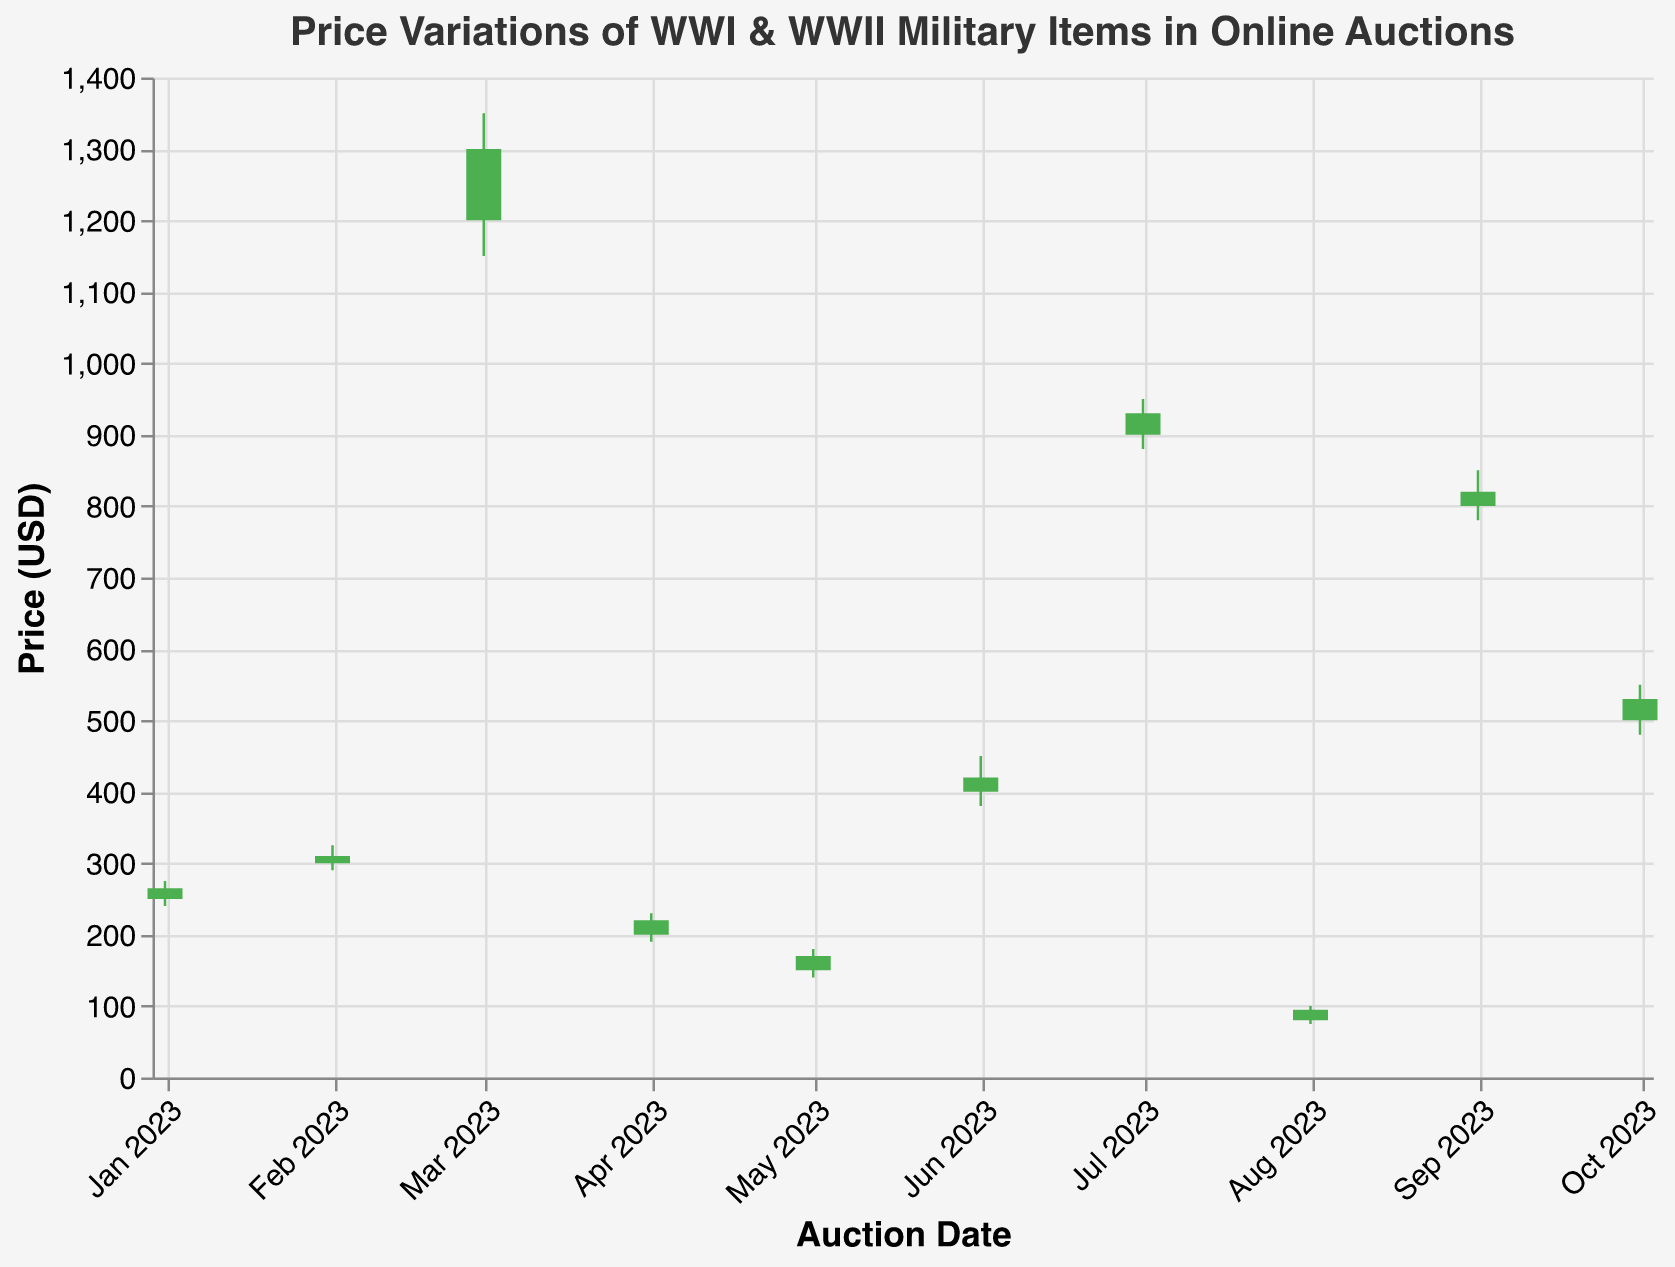What's the highest price recorded for the US WWI M1917 Enfield Rifle? The plot marks the 'high' prices for each item. For "US WWI M1917 Enfield Rifle," the highest price recorded is 950 dollars.
Answer: 950 USD Which item had the highest closing price in February 2023? The x-axis represents the dates and the items are listed with their prices. For February 2023, the "German WWII Stahlhelm M40" closed at 310 dollars, which is the highest closing price among items listed in February.
Answer: German WWII Stahlhelm M40 How does the closing price of the German WWII Luftwaffe Flight Jacket in October compare to its opening price? By comparing the opening price (500 USD) with the closing price (530 USD) for "German WWII Luftwaffe Flight Jacket," you can see that the closing price is higher.
Answer: The closing price is higher Which item had the greatest range between its highest and lowest price? The range is calculated by subtracting the lowest price from the highest price for each item. "US WWII M1 Garand Rifle" has the highest range (1350 - 1150 = 200 USD).
Answer: US WWII M1 Garand Rifle What is the overall trend for the closing prices of the British WWI Brodie Helmet from January to October 2023? Observing the data for the British WWI Brodie Helmet in January (Close: 265 USD) and in October (not listed again), the trend cannot be determined for the entire period as it is only listed in January.
Answer: Not enough data Calculate the average closing price for the rifles listed in the data. Adding the closing prices of the rifles (1300 USD for US WWII M1 Garand Rifle, 930 USD for US WWI M1917 Enfield Rifle, 820 USD for British WWI P14 Rifle) and then dividing by the number of rifles (3): (1300 + 930 + 820)/3 = 1016.67 USD.
Answer: 1016.67 USD Which item had the lowest opening price, and how much was it? By comparing the opening prices of all items, the "Soviet WWII Ushanka" has the lowest opening price: 80 USD.
Answer: Soviet WWII Ushanka, 80 USD Which item saw an increase in its closing price compared to its opening price in March 2023? In March 2023, "US WWII M1 Garand Rifle" has an opening price of 1200 USD and a closing price of 1300 USD which indicates an increase.
Answer: US WWII M1 Garand Rifle How many items have their closing price lower than their opening price? By comparing each item's opening and closing prices, 3 items have a closing price lower than their opening price: British WWI Brodie Helmet, French WWI Adrian Helmet, British WWII Battle Dress Uniform.
Answer: 3 items 